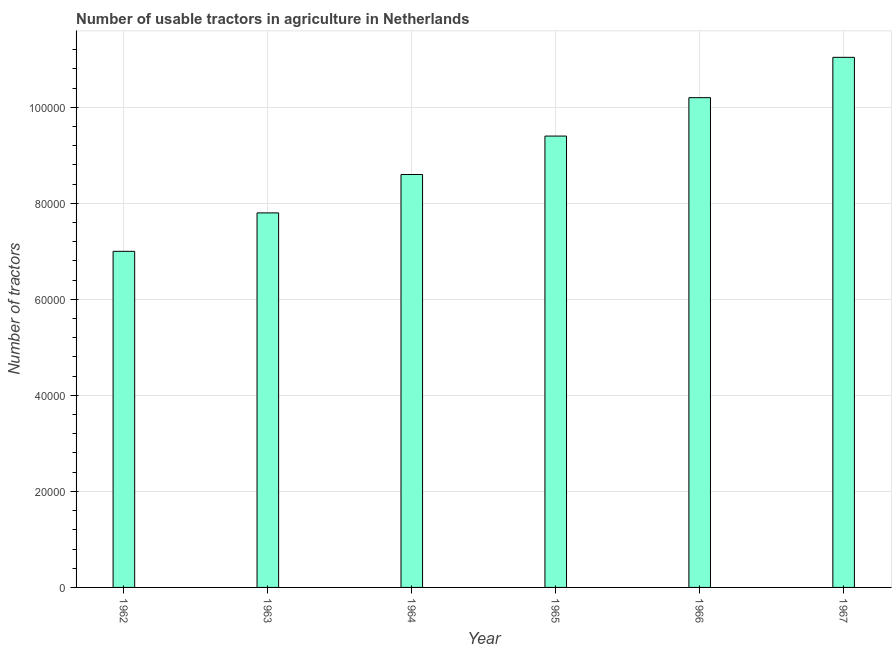Does the graph contain any zero values?
Offer a terse response. No. Does the graph contain grids?
Keep it short and to the point. Yes. What is the title of the graph?
Make the answer very short. Number of usable tractors in agriculture in Netherlands. What is the label or title of the Y-axis?
Provide a succinct answer. Number of tractors. What is the number of tractors in 1963?
Provide a succinct answer. 7.80e+04. Across all years, what is the maximum number of tractors?
Your answer should be very brief. 1.10e+05. Across all years, what is the minimum number of tractors?
Your answer should be very brief. 7.00e+04. In which year was the number of tractors maximum?
Your answer should be very brief. 1967. In which year was the number of tractors minimum?
Give a very brief answer. 1962. What is the sum of the number of tractors?
Offer a terse response. 5.40e+05. What is the difference between the number of tractors in 1962 and 1966?
Provide a short and direct response. -3.20e+04. What is the average number of tractors per year?
Offer a terse response. 9.01e+04. In how many years, is the number of tractors greater than 56000 ?
Your answer should be compact. 6. What is the ratio of the number of tractors in 1962 to that in 1964?
Give a very brief answer. 0.81. Is the difference between the number of tractors in 1962 and 1967 greater than the difference between any two years?
Your response must be concise. Yes. What is the difference between the highest and the second highest number of tractors?
Provide a short and direct response. 8400. Is the sum of the number of tractors in 1963 and 1967 greater than the maximum number of tractors across all years?
Keep it short and to the point. Yes. What is the difference between the highest and the lowest number of tractors?
Make the answer very short. 4.04e+04. In how many years, is the number of tractors greater than the average number of tractors taken over all years?
Give a very brief answer. 3. How many years are there in the graph?
Offer a very short reply. 6. What is the Number of tractors in 1962?
Give a very brief answer. 7.00e+04. What is the Number of tractors in 1963?
Your response must be concise. 7.80e+04. What is the Number of tractors of 1964?
Your answer should be compact. 8.60e+04. What is the Number of tractors in 1965?
Offer a very short reply. 9.40e+04. What is the Number of tractors in 1966?
Your response must be concise. 1.02e+05. What is the Number of tractors in 1967?
Your answer should be very brief. 1.10e+05. What is the difference between the Number of tractors in 1962 and 1963?
Your answer should be very brief. -8000. What is the difference between the Number of tractors in 1962 and 1964?
Offer a very short reply. -1.60e+04. What is the difference between the Number of tractors in 1962 and 1965?
Offer a very short reply. -2.40e+04. What is the difference between the Number of tractors in 1962 and 1966?
Provide a short and direct response. -3.20e+04. What is the difference between the Number of tractors in 1962 and 1967?
Offer a terse response. -4.04e+04. What is the difference between the Number of tractors in 1963 and 1964?
Your answer should be very brief. -8000. What is the difference between the Number of tractors in 1963 and 1965?
Your response must be concise. -1.60e+04. What is the difference between the Number of tractors in 1963 and 1966?
Give a very brief answer. -2.40e+04. What is the difference between the Number of tractors in 1963 and 1967?
Make the answer very short. -3.24e+04. What is the difference between the Number of tractors in 1964 and 1965?
Offer a very short reply. -8000. What is the difference between the Number of tractors in 1964 and 1966?
Give a very brief answer. -1.60e+04. What is the difference between the Number of tractors in 1964 and 1967?
Offer a terse response. -2.44e+04. What is the difference between the Number of tractors in 1965 and 1966?
Keep it short and to the point. -8000. What is the difference between the Number of tractors in 1965 and 1967?
Provide a succinct answer. -1.64e+04. What is the difference between the Number of tractors in 1966 and 1967?
Give a very brief answer. -8400. What is the ratio of the Number of tractors in 1962 to that in 1963?
Offer a very short reply. 0.9. What is the ratio of the Number of tractors in 1962 to that in 1964?
Your response must be concise. 0.81. What is the ratio of the Number of tractors in 1962 to that in 1965?
Ensure brevity in your answer.  0.74. What is the ratio of the Number of tractors in 1962 to that in 1966?
Make the answer very short. 0.69. What is the ratio of the Number of tractors in 1962 to that in 1967?
Offer a terse response. 0.63. What is the ratio of the Number of tractors in 1963 to that in 1964?
Provide a succinct answer. 0.91. What is the ratio of the Number of tractors in 1963 to that in 1965?
Give a very brief answer. 0.83. What is the ratio of the Number of tractors in 1963 to that in 1966?
Make the answer very short. 0.77. What is the ratio of the Number of tractors in 1963 to that in 1967?
Make the answer very short. 0.71. What is the ratio of the Number of tractors in 1964 to that in 1965?
Your answer should be very brief. 0.92. What is the ratio of the Number of tractors in 1964 to that in 1966?
Provide a succinct answer. 0.84. What is the ratio of the Number of tractors in 1964 to that in 1967?
Give a very brief answer. 0.78. What is the ratio of the Number of tractors in 1965 to that in 1966?
Make the answer very short. 0.92. What is the ratio of the Number of tractors in 1965 to that in 1967?
Offer a very short reply. 0.85. What is the ratio of the Number of tractors in 1966 to that in 1967?
Give a very brief answer. 0.92. 